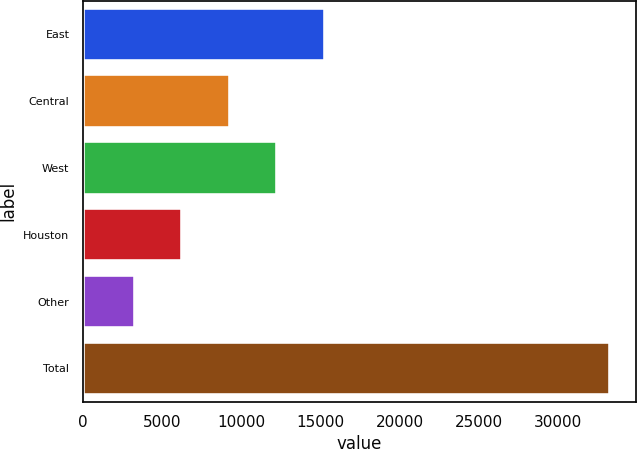Convert chart to OTSL. <chart><loc_0><loc_0><loc_500><loc_500><bar_chart><fcel>East<fcel>Central<fcel>West<fcel>Houston<fcel>Other<fcel>Total<nl><fcel>15295.6<fcel>9299.8<fcel>12297.7<fcel>6301.9<fcel>3304<fcel>33283<nl></chart> 